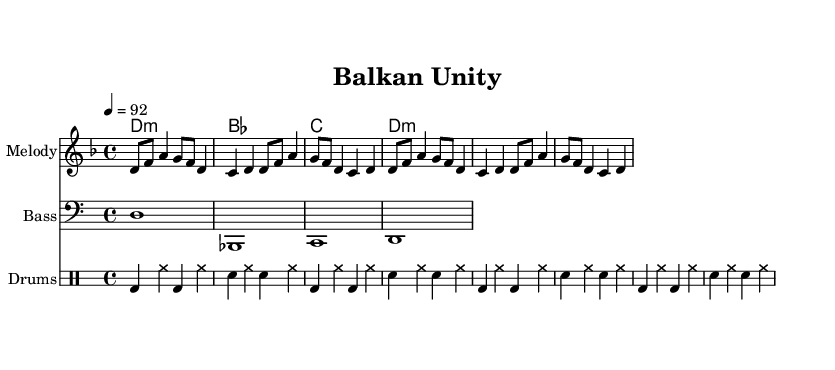What is the key signature of this music? The key signature is D minor, indicated by one flat (B flat). We can determine it by looking at the key signature markings at the beginning of the staff.
Answer: D minor What is the time signature of this music? The time signature is 4/4, which is indicated at the start of the piece. This means there are four beats in each measure and a quarter note gets one beat.
Answer: 4/4 What is the specified tempo of this composition? The tempo is marked at 92 beats per minute, shown in the tempo indication within the score. This guides performers on how fast to play the piece.
Answer: 92 How many measures are present in the melody section? The melody section contains four measures as seen by the grouping of the notes divided into four distinct segments, each separated by a bar line.
Answer: 4 What kind of drum pattern is used in this rap? The drum pattern consists of bass drum (bd), snare drum (sn), and hi-hat (hh), indicated by the specific notations in the drummode section. This pattern reflects common elements used in hip hop music to establish rhythm and groove.
Answer: Bass, snare, hi-hat Which instrument provides the harmonic foundation in this piece? The harmonic foundation is provided by the chord changes listed under "ChordNames". The chords designated with labels such as "d1:m" and "bes" support the overall structure of the composition, typical in hip hop for creating depth.
Answer: Chords What is the role of the bass line in this composition? The bass line plays a fundamental role by establishing the root notes of the chords, anchoring the harmony, and reinforcing the rhythmic groove of the track. This is crucial for providing support and depth in hip hop music.
Answer: Root notes 